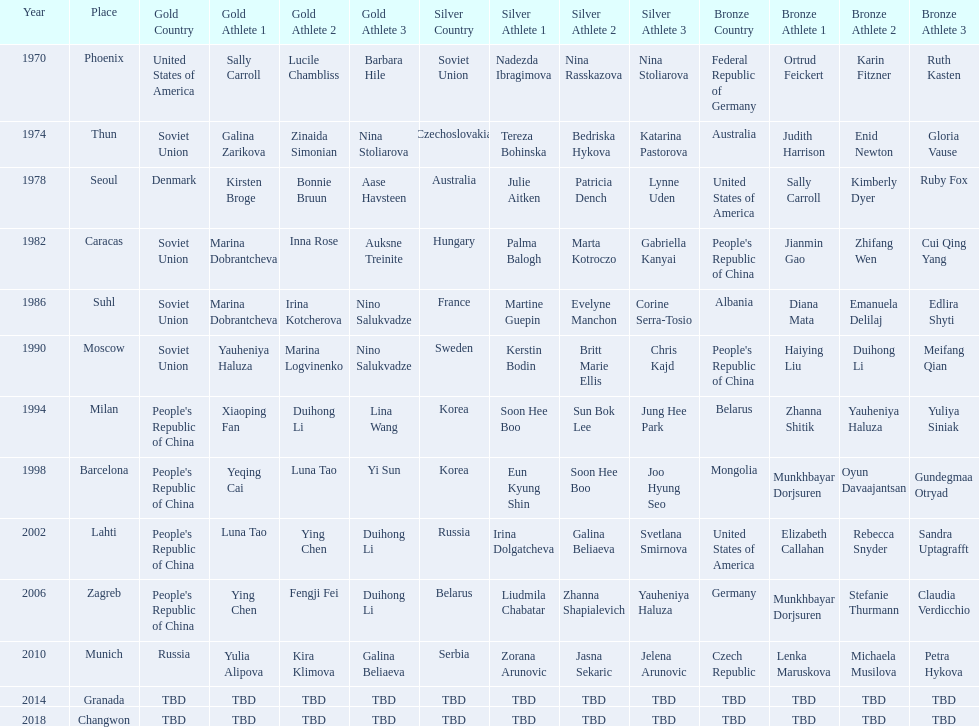What is the number of total bronze medals that germany has won? 1. 